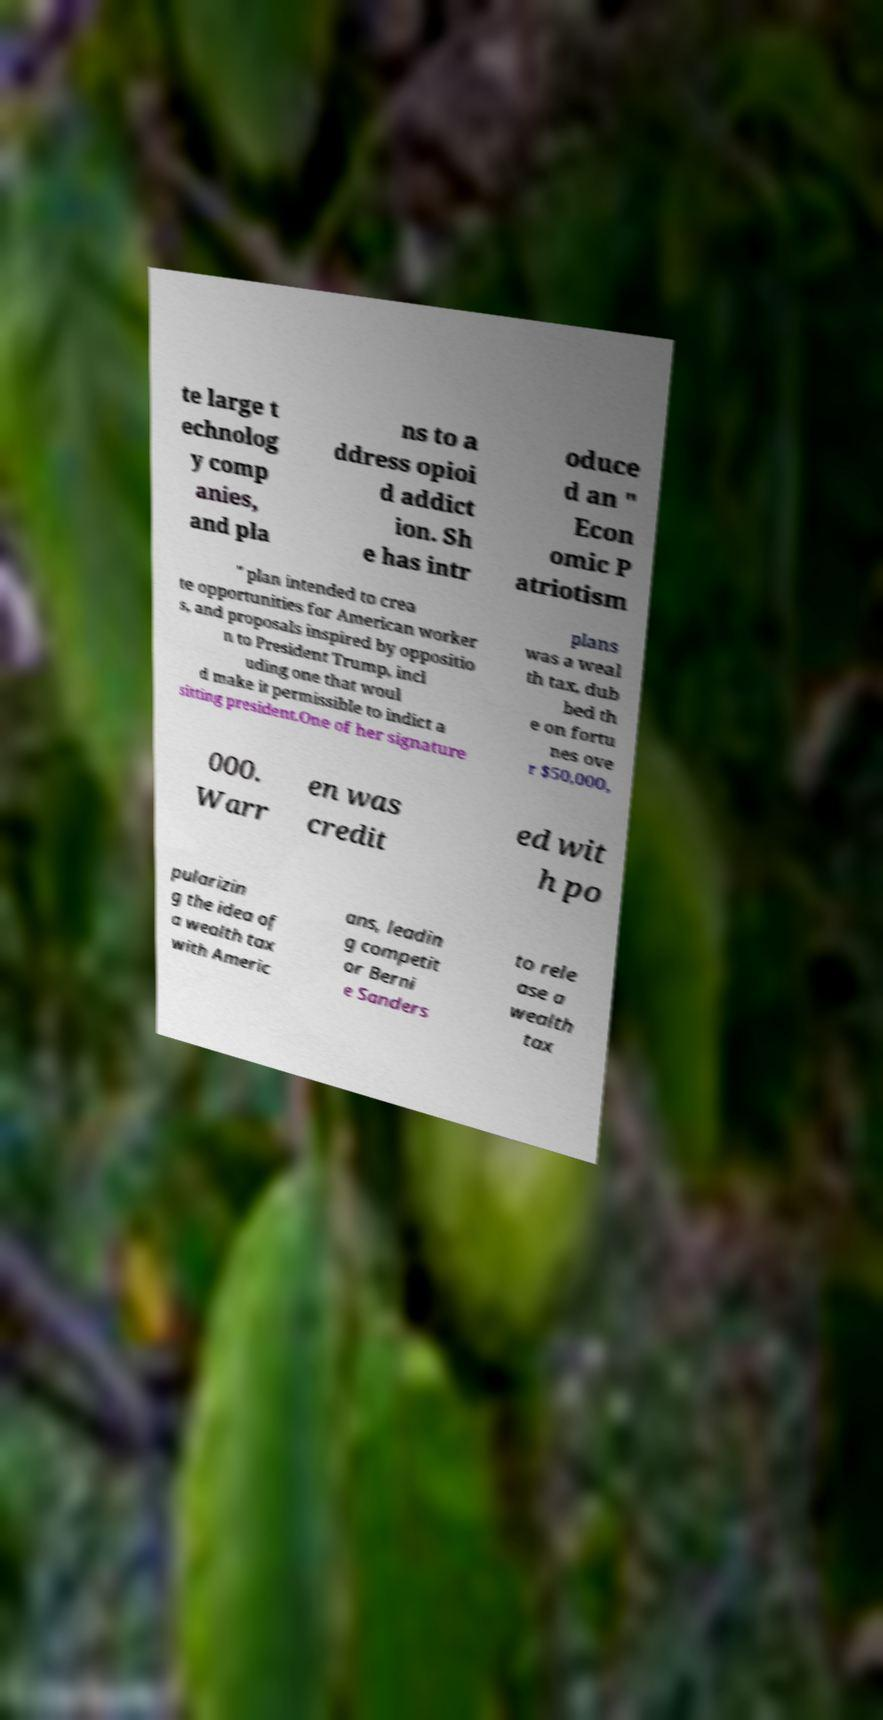What messages or text are displayed in this image? I need them in a readable, typed format. te large t echnolog y comp anies, and pla ns to a ddress opioi d addict ion. Sh e has intr oduce d an " Econ omic P atriotism " plan intended to crea te opportunities for American worker s, and proposals inspired by oppositio n to President Trump, incl uding one that woul d make it permissible to indict a sitting president.One of her signature plans was a weal th tax, dub bed th e on fortu nes ove r $50,000, 000. Warr en was credit ed wit h po pularizin g the idea of a wealth tax with Americ ans, leadin g competit or Berni e Sanders to rele ase a wealth tax 